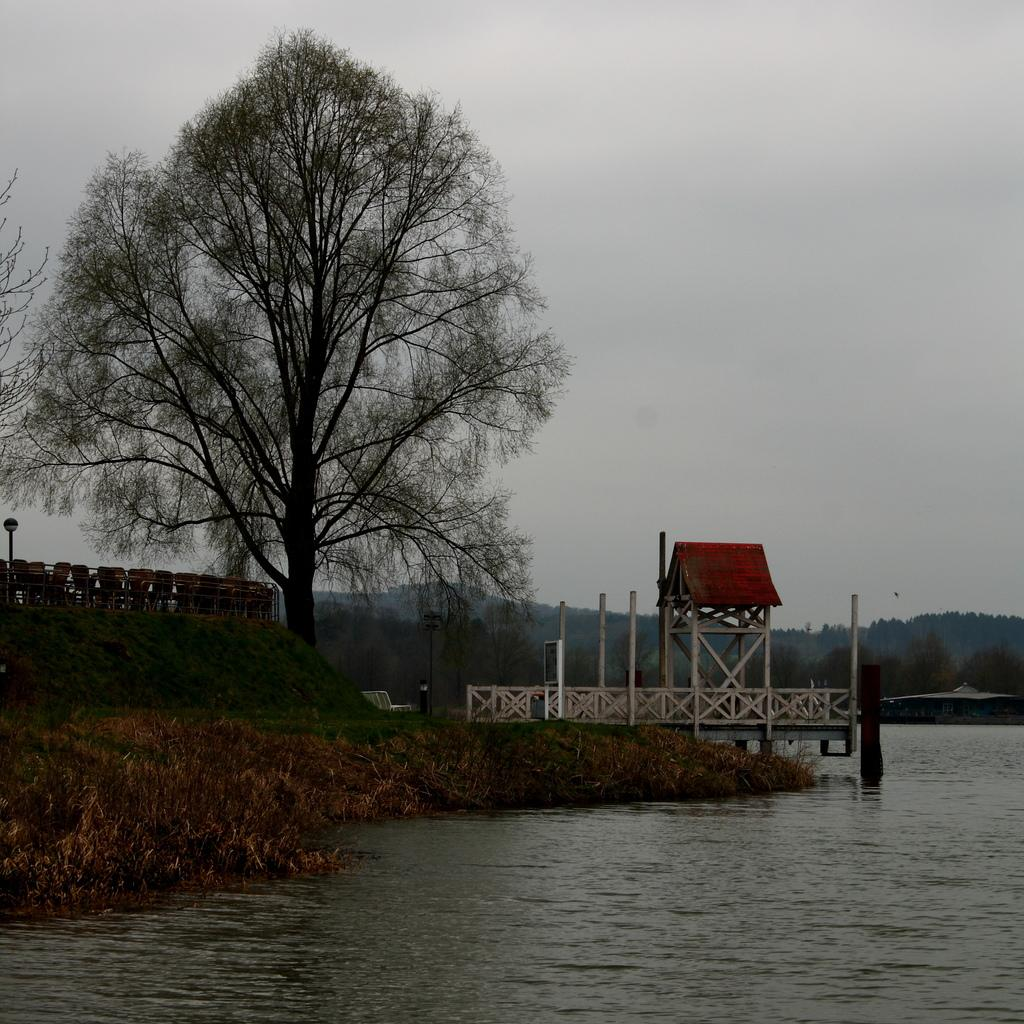What body of water is visible in the image? There is a lake in the image. What type of vegetation is near the lake? There are trees beside the lake. What type of structures can be seen in the image? There are buildings in the image. What plot of land is the committee discussing in the image? There is no plot of land or committee present in the image; it features a lake, trees, and buildings. 